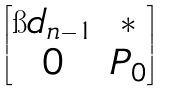Convert formula to latex. <formula><loc_0><loc_0><loc_500><loc_500>\begin{bmatrix} \i d _ { n - 1 } & * \\ 0 & P _ { 0 } \end{bmatrix}</formula> 